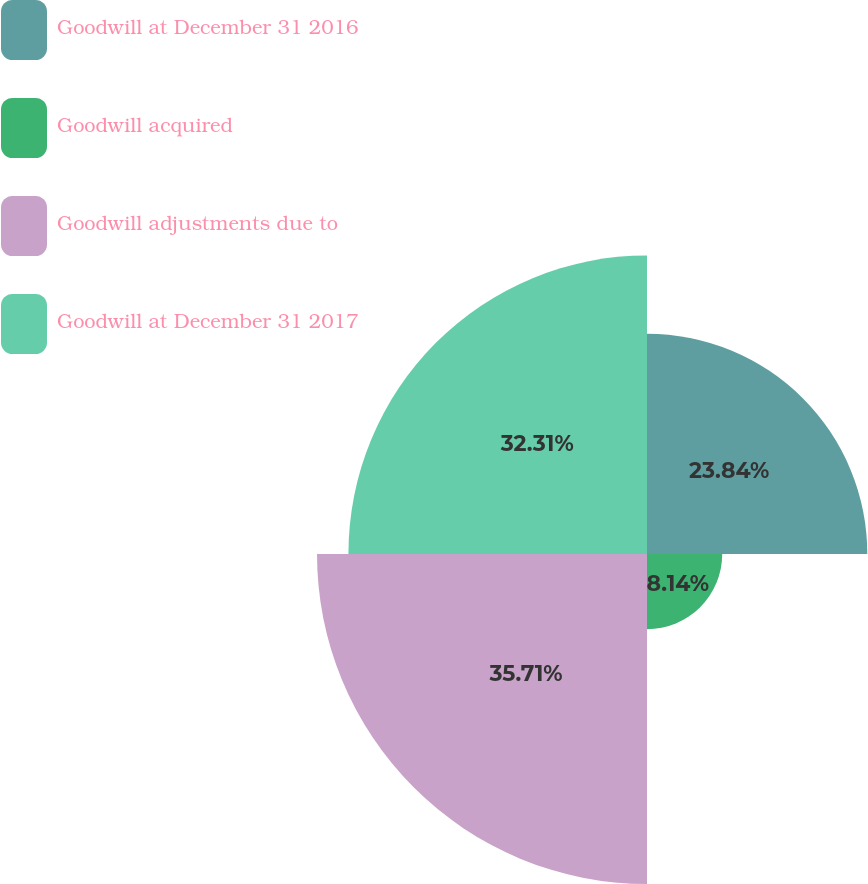<chart> <loc_0><loc_0><loc_500><loc_500><pie_chart><fcel>Goodwill at December 31 2016<fcel>Goodwill acquired<fcel>Goodwill adjustments due to<fcel>Goodwill at December 31 2017<nl><fcel>23.84%<fcel>8.14%<fcel>35.71%<fcel>32.31%<nl></chart> 